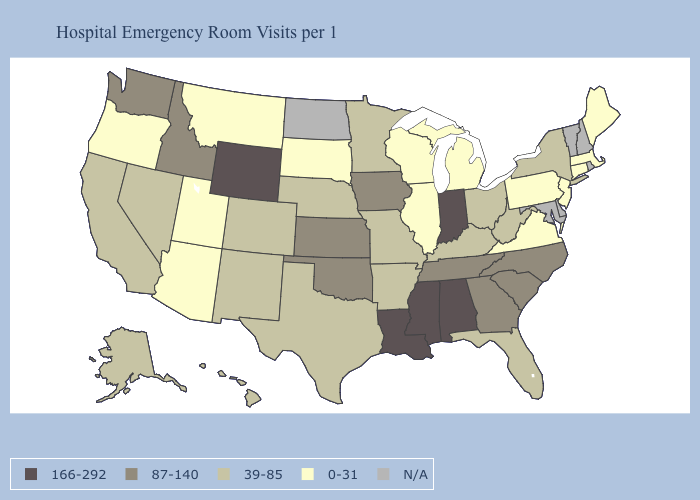Does Missouri have the lowest value in the USA?
Keep it brief. No. Which states have the lowest value in the Northeast?
Short answer required. Connecticut, Maine, Massachusetts, New Jersey, Pennsylvania. Name the states that have a value in the range 87-140?
Be succinct. Georgia, Idaho, Iowa, Kansas, North Carolina, Oklahoma, South Carolina, Tennessee, Washington. What is the highest value in states that border New York?
Quick response, please. 0-31. What is the lowest value in the USA?
Be succinct. 0-31. Name the states that have a value in the range 166-292?
Be succinct. Alabama, Indiana, Louisiana, Mississippi, Wyoming. What is the value of North Dakota?
Be succinct. N/A. Does Louisiana have the highest value in the USA?
Keep it brief. Yes. Name the states that have a value in the range 166-292?
Write a very short answer. Alabama, Indiana, Louisiana, Mississippi, Wyoming. Among the states that border West Virginia , does Ohio have the lowest value?
Be succinct. No. What is the value of Iowa?
Concise answer only. 87-140. What is the value of Maryland?
Write a very short answer. N/A. Is the legend a continuous bar?
Be succinct. No. Name the states that have a value in the range 166-292?
Quick response, please. Alabama, Indiana, Louisiana, Mississippi, Wyoming. 